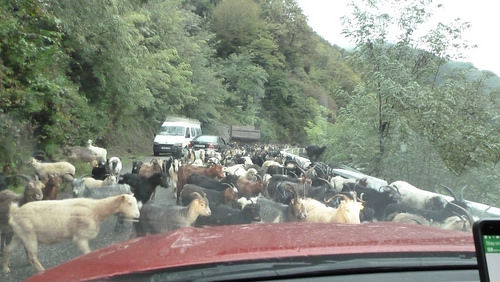<image>
Is the cows in the foliage? No. The cows is not contained within the foliage. These objects have a different spatial relationship. Where is the car one in relation to the car two? Is it to the right of the car two? No. The car one is not to the right of the car two. The horizontal positioning shows a different relationship. 